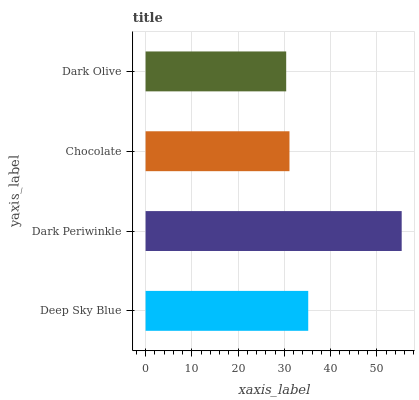Is Dark Olive the minimum?
Answer yes or no. Yes. Is Dark Periwinkle the maximum?
Answer yes or no. Yes. Is Chocolate the minimum?
Answer yes or no. No. Is Chocolate the maximum?
Answer yes or no. No. Is Dark Periwinkle greater than Chocolate?
Answer yes or no. Yes. Is Chocolate less than Dark Periwinkle?
Answer yes or no. Yes. Is Chocolate greater than Dark Periwinkle?
Answer yes or no. No. Is Dark Periwinkle less than Chocolate?
Answer yes or no. No. Is Deep Sky Blue the high median?
Answer yes or no. Yes. Is Chocolate the low median?
Answer yes or no. Yes. Is Chocolate the high median?
Answer yes or no. No. Is Deep Sky Blue the low median?
Answer yes or no. No. 